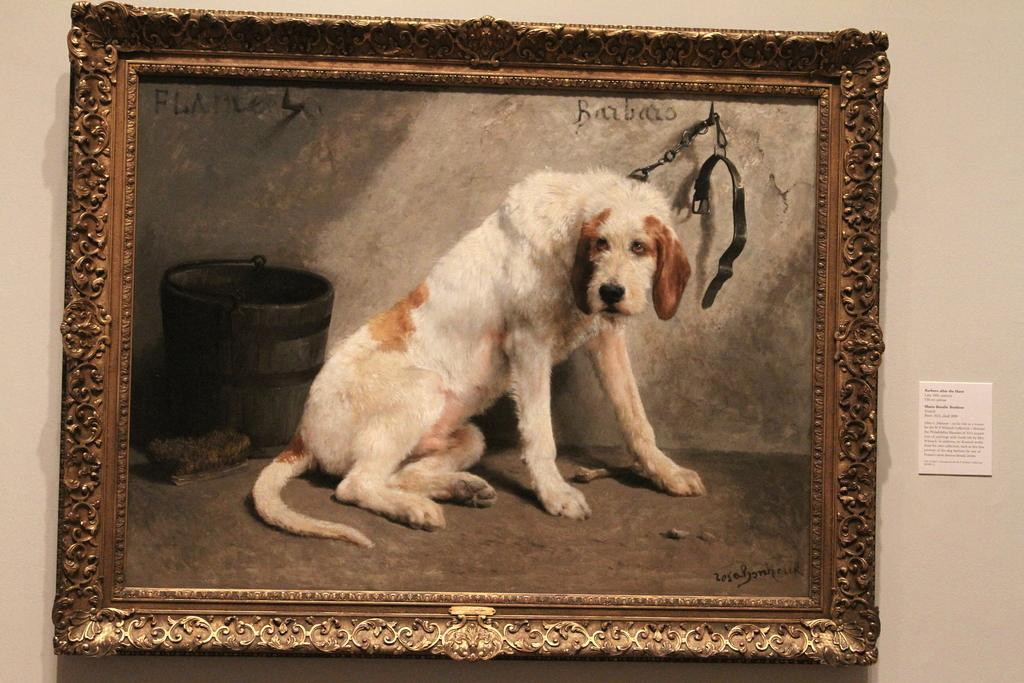What is the main subject in the center of the image? There is a photo frame in the center of the image. What is depicted in the photo frame? The photo frame contains a picture of a dog. Where is the photo frame located in the image? The photo frame is placed on the wall. How does the photo frame sort the liquid in the image? There is no liquid present in the image, and the photo frame does not have the ability to sort anything. 